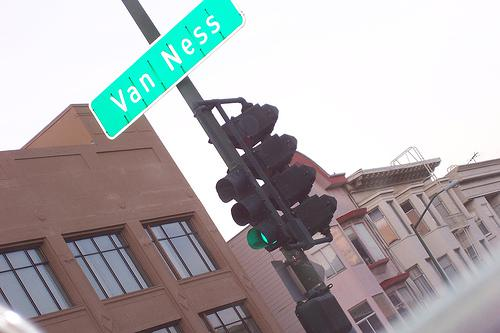Question: where are the windows?
Choices:
A. On the car.
B. On the building.
C. On the truck.
D. On the bike.
Answer with the letter. Answer: B Question: what is the street name?
Choices:
A. An Vess.
B. Nestle.
C. Aness.
D. Van Ness.
Answer with the letter. Answer: D 